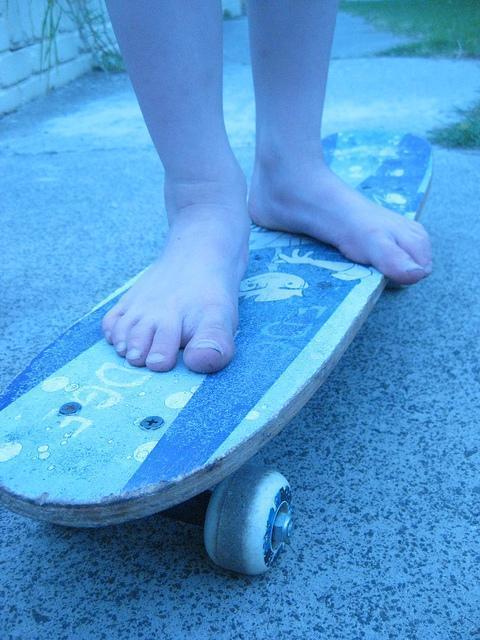How many toes are over the edge of the board?
Give a very brief answer. 5. 